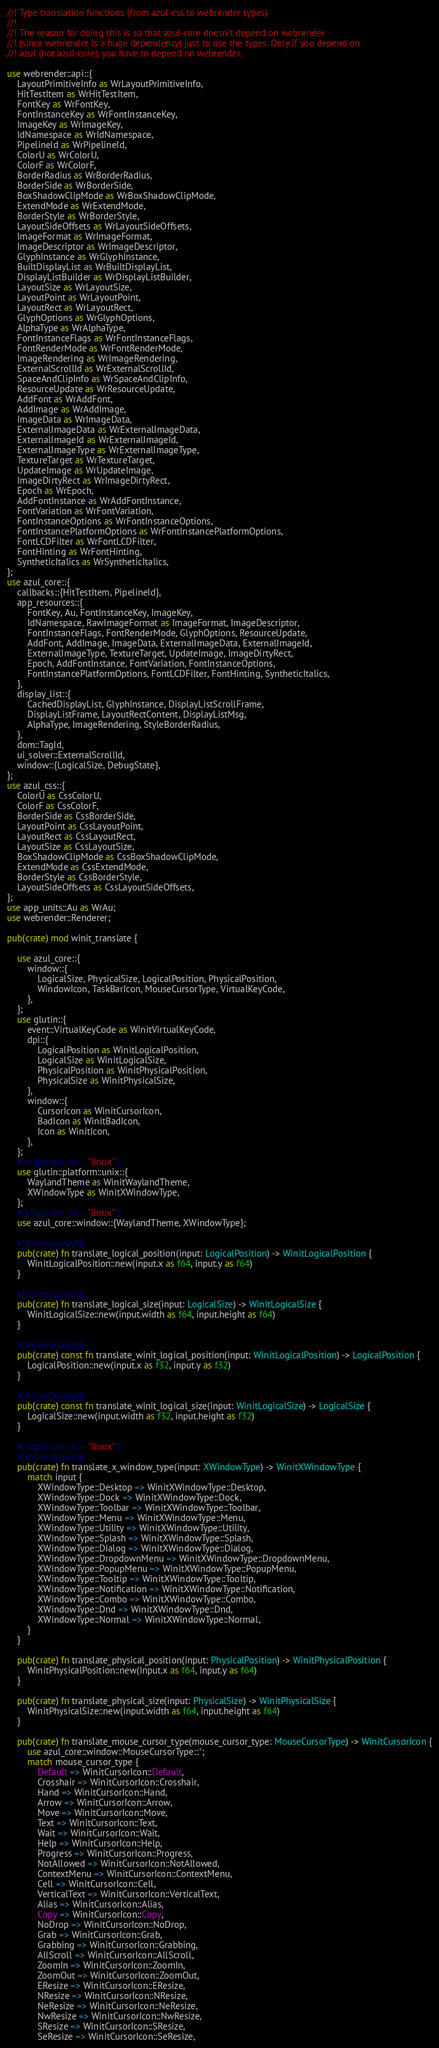<code> <loc_0><loc_0><loc_500><loc_500><_Rust_>//! Type translation functions (from azul-css to webrender types)
//!
//! The reason for doing this is so that azul-core doesn't depend on webrender
//! (since webrender is a huge dependency) just to use the types. Only if you depend on
//! azul (not azul-core), you have to depend on webrender.

use webrender::api::{
    LayoutPrimitiveInfo as WrLayoutPrimitiveInfo,
    HitTestItem as WrHitTestItem,
    FontKey as WrFontKey,
    FontInstanceKey as WrFontInstanceKey,
    ImageKey as WrImageKey,
    IdNamespace as WrIdNamespace,
    PipelineId as WrPipelineId,
    ColorU as WrColorU,
    ColorF as WrColorF,
    BorderRadius as WrBorderRadius,
    BorderSide as WrBorderSide,
    BoxShadowClipMode as WrBoxShadowClipMode,
    ExtendMode as WrExtendMode,
    BorderStyle as WrBorderStyle,
    LayoutSideOffsets as WrLayoutSideOffsets,
    ImageFormat as WrImageFormat,
    ImageDescriptor as WrImageDescriptor,
    GlyphInstance as WrGlyphInstance,
    BuiltDisplayList as WrBuiltDisplayList,
    DisplayListBuilder as WrDisplayListBuilder,
    LayoutSize as WrLayoutSize,
    LayoutPoint as WrLayoutPoint,
    LayoutRect as WrLayoutRect,
    GlyphOptions as WrGlyphOptions,
    AlphaType as WrAlphaType,
    FontInstanceFlags as WrFontInstanceFlags,
    FontRenderMode as WrFontRenderMode,
    ImageRendering as WrImageRendering,
    ExternalScrollId as WrExternalScrollId,
    SpaceAndClipInfo as WrSpaceAndClipInfo,
    ResourceUpdate as WrResourceUpdate,
    AddFont as WrAddFont,
    AddImage as WrAddImage,
    ImageData as WrImageData,
    ExternalImageData as WrExternalImageData,
    ExternalImageId as WrExternalImageId,
    ExternalImageType as WrExternalImageType,
    TextureTarget as WrTextureTarget,
    UpdateImage as WrUpdateImage,
    ImageDirtyRect as WrImageDirtyRect,
    Epoch as WrEpoch,
    AddFontInstance as WrAddFontInstance,
    FontVariation as WrFontVariation,
    FontInstanceOptions as WrFontInstanceOptions,
    FontInstancePlatformOptions as WrFontInstancePlatformOptions,
    FontLCDFilter as WrFontLCDFilter,
    FontHinting as WrFontHinting,
    SyntheticItalics as WrSyntheticItalics,
};
use azul_core::{
    callbacks::{HitTestItem, PipelineId},
    app_resources::{
        FontKey, Au, FontInstanceKey, ImageKey,
        IdNamespace, RawImageFormat as ImageFormat, ImageDescriptor,
        FontInstanceFlags, FontRenderMode, GlyphOptions, ResourceUpdate,
        AddFont, AddImage, ImageData, ExternalImageData, ExternalImageId,
        ExternalImageType, TextureTarget, UpdateImage, ImageDirtyRect,
        Epoch, AddFontInstance, FontVariation, FontInstanceOptions,
        FontInstancePlatformOptions, FontLCDFilter, FontHinting, SyntheticItalics,
    },
    display_list::{
        CachedDisplayList, GlyphInstance, DisplayListScrollFrame,
        DisplayListFrame, LayoutRectContent, DisplayListMsg,
        AlphaType, ImageRendering, StyleBorderRadius,
    },
    dom::TagId,
    ui_solver::ExternalScrollId,
    window::{LogicalSize, DebugState},
};
use azul_css::{
    ColorU as CssColorU,
    ColorF as CssColorF,
    BorderSide as CssBorderSide,
    LayoutPoint as CssLayoutPoint,
    LayoutRect as CssLayoutRect,
    LayoutSize as CssLayoutSize,
    BoxShadowClipMode as CssBoxShadowClipMode,
    ExtendMode as CssExtendMode,
    BorderStyle as CssBorderStyle,
    LayoutSideOffsets as CssLayoutSideOffsets,
};
use app_units::Au as WrAu;
use webrender::Renderer;

pub(crate) mod winit_translate {

    use azul_core::{
        window::{
            LogicalSize, PhysicalSize, LogicalPosition, PhysicalPosition,
            WindowIcon, TaskBarIcon, MouseCursorType, VirtualKeyCode,
        },
    };
    use glutin::{
        event::VirtualKeyCode as WinitVirtualKeyCode,
        dpi::{
            LogicalPosition as WinitLogicalPosition,
            LogicalSize as WinitLogicalSize,
            PhysicalPosition as WinitPhysicalPosition,
            PhysicalSize as WinitPhysicalSize,
        },
        window::{
            CursorIcon as WinitCursorIcon,
            BadIcon as WinitBadIcon,
            Icon as WinitIcon,
        },
    };
    #[cfg(target_os = "linux")]
    use glutin::platform::unix::{
        WaylandTheme as WinitWaylandTheme,
        XWindowType as WinitXWindowType,
    };
    #[cfg(target_os = "linux")]
    use azul_core::window::{WaylandTheme, XWindowType};

    #[inline(always)]
    pub(crate) fn translate_logical_position(input: LogicalPosition) -> WinitLogicalPosition {
        WinitLogicalPosition::new(input.x as f64, input.y as f64)
    }

    #[inline(always)]
    pub(crate) fn translate_logical_size(input: LogicalSize) -> WinitLogicalSize {
        WinitLogicalSize::new(input.width as f64, input.height as f64)
    }

    #[inline(always)]
    pub(crate) const fn translate_winit_logical_position(input: WinitLogicalPosition) -> LogicalPosition {
        LogicalPosition::new(input.x as f32, input.y as f32)
    }

    #[inline(always)]
    pub(crate) const fn translate_winit_logical_size(input: WinitLogicalSize) -> LogicalSize {
        LogicalSize::new(input.width as f32, input.height as f32)
    }

    #[cfg(target_os = "linux")]
    #[inline(always)]
    pub(crate) fn translate_x_window_type(input: XWindowType) -> WinitXWindowType {
        match input {
            XWindowType::Desktop => WinitXWindowType::Desktop,
            XWindowType::Dock => WinitXWindowType::Dock,
            XWindowType::Toolbar => WinitXWindowType::Toolbar,
            XWindowType::Menu => WinitXWindowType::Menu,
            XWindowType::Utility => WinitXWindowType::Utility,
            XWindowType::Splash => WinitXWindowType::Splash,
            XWindowType::Dialog => WinitXWindowType::Dialog,
            XWindowType::DropdownMenu => WinitXWindowType::DropdownMenu,
            XWindowType::PopupMenu => WinitXWindowType::PopupMenu,
            XWindowType::Tooltip => WinitXWindowType::Tooltip,
            XWindowType::Notification => WinitXWindowType::Notification,
            XWindowType::Combo => WinitXWindowType::Combo,
            XWindowType::Dnd => WinitXWindowType::Dnd,
            XWindowType::Normal => WinitXWindowType::Normal,
        }
    }

    pub(crate) fn translate_physical_position(input: PhysicalPosition) -> WinitPhysicalPosition {
        WinitPhysicalPosition::new(input.x as f64, input.y as f64)
    }

    pub(crate) fn translate_physical_size(input: PhysicalSize) -> WinitPhysicalSize {
        WinitPhysicalSize::new(input.width as f64, input.height as f64)
    }

    pub(crate) fn translate_mouse_cursor_type(mouse_cursor_type: MouseCursorType) -> WinitCursorIcon {
        use azul_core::window::MouseCursorType::*;
        match mouse_cursor_type {
            Default => WinitCursorIcon::Default,
            Crosshair => WinitCursorIcon::Crosshair,
            Hand => WinitCursorIcon::Hand,
            Arrow => WinitCursorIcon::Arrow,
            Move => WinitCursorIcon::Move,
            Text => WinitCursorIcon::Text,
            Wait => WinitCursorIcon::Wait,
            Help => WinitCursorIcon::Help,
            Progress => WinitCursorIcon::Progress,
            NotAllowed => WinitCursorIcon::NotAllowed,
            ContextMenu => WinitCursorIcon::ContextMenu,
            Cell => WinitCursorIcon::Cell,
            VerticalText => WinitCursorIcon::VerticalText,
            Alias => WinitCursorIcon::Alias,
            Copy => WinitCursorIcon::Copy,
            NoDrop => WinitCursorIcon::NoDrop,
            Grab => WinitCursorIcon::Grab,
            Grabbing => WinitCursorIcon::Grabbing,
            AllScroll => WinitCursorIcon::AllScroll,
            ZoomIn => WinitCursorIcon::ZoomIn,
            ZoomOut => WinitCursorIcon::ZoomOut,
            EResize => WinitCursorIcon::EResize,
            NResize => WinitCursorIcon::NResize,
            NeResize => WinitCursorIcon::NeResize,
            NwResize => WinitCursorIcon::NwResize,
            SResize => WinitCursorIcon::SResize,
            SeResize => WinitCursorIcon::SeResize,</code> 